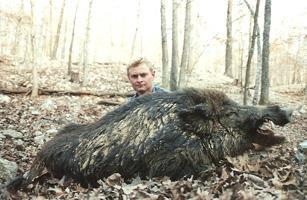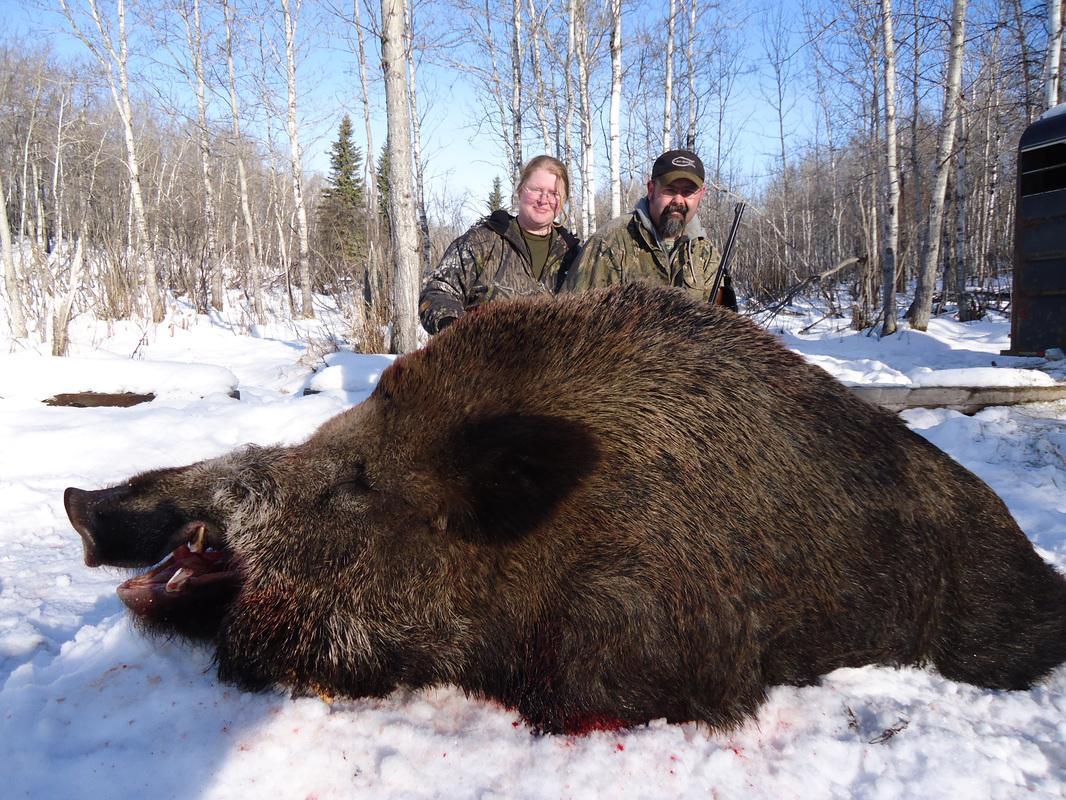The first image is the image on the left, the second image is the image on the right. Assess this claim about the two images: "A man with a gun poses behind a downed boar in the right image.". Correct or not? Answer yes or no. Yes. The first image is the image on the left, the second image is the image on the right. For the images displayed, is the sentence "A single person is posing with a dead pig in the image on the left." factually correct? Answer yes or no. Yes. 